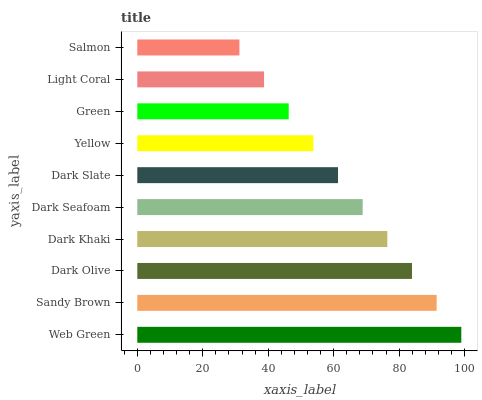Is Salmon the minimum?
Answer yes or no. Yes. Is Web Green the maximum?
Answer yes or no. Yes. Is Sandy Brown the minimum?
Answer yes or no. No. Is Sandy Brown the maximum?
Answer yes or no. No. Is Web Green greater than Sandy Brown?
Answer yes or no. Yes. Is Sandy Brown less than Web Green?
Answer yes or no. Yes. Is Sandy Brown greater than Web Green?
Answer yes or no. No. Is Web Green less than Sandy Brown?
Answer yes or no. No. Is Dark Seafoam the high median?
Answer yes or no. Yes. Is Dark Slate the low median?
Answer yes or no. Yes. Is Green the high median?
Answer yes or no. No. Is Web Green the low median?
Answer yes or no. No. 